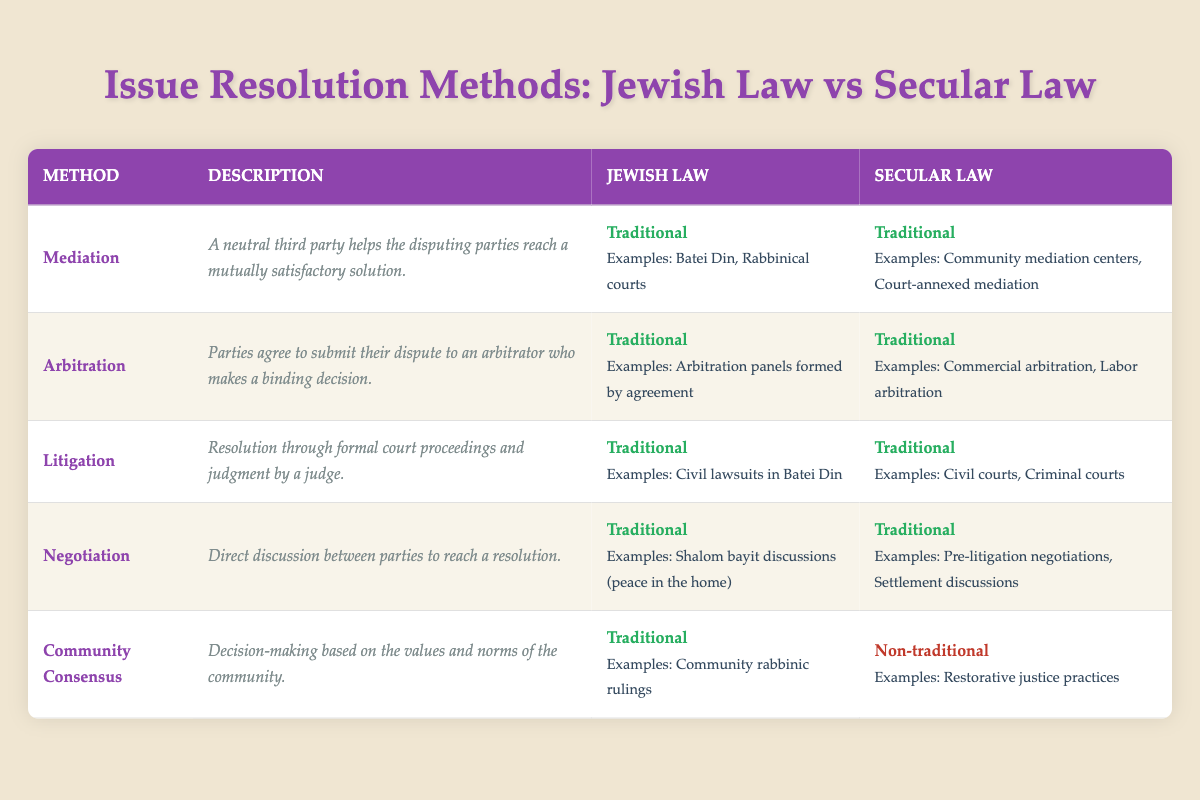What issue resolution method does Jewish law have in common with secular law? Both Jewish law and secular law include Mediation, Arbitration, Litigation, and Negotiation as traditional methods for issue resolution. These methods are listed under their respective columns in the table, and both legal systems feature the same methods classified as traditional.
Answer: Mediation, Arbitration, Litigation, Negotiation Is Community Consensus considered a traditional method in secular law? In the table, Community Consensus is marked as traditional in Jewish law but is noted as non-traditional in secular law. This distinction is explicitly stated in the last row of the table, indicating that it does not fit the traditional model in secular law.
Answer: No What are the examples of Mediation in Jewish law? The examples provided in the table for Mediation in Jewish law are Batei Din and Rabbinical courts, which are clearly listed under the Jewish law column for that method.
Answer: Batei Din, Rabbinical courts How many issue resolution methods are classified as traditional in both Jewish and secular law? By reviewing each row in the table, we see that 4 out of the 5 methods listed (Mediation, Arbitration, Litigation, and Negotiation) are classified as traditional in both legal systems. Community Consensus is the only exception, making it 4 methods in total that share this classification.
Answer: 4 Is it true that all listed methods in Jewish law have examples provided? Upon checking each method in the table, every method listed—Mediation, Arbitration, Litigation, Negotiation, and Community Consensus—has examples included under the Jewish law column. Therefore, the statement is true.
Answer: Yes Which issue resolution method has different classifications between Jewish and secular law? Community Consensus is the only method where Jewish law classifies it as traditional, while secular law classifies it as non-traditional. This unique distinction is found when comparing the respective classifications in the last row of the table.
Answer: Community Consensus What method involves a neutral third party in both legal systems? The method that involves a neutral third party is Mediation, as indicated in the descriptions for both Jewish law and secular law in the table. It explicitly states in both columns that a neutral third party helps the disputing parties reach a mutually satisfactory solution.
Answer: Mediation What would be the total count of traditional methods in Jewish law if Community Consensus were excluded? From the table, there are 5 methods total, 4 of which are classified as traditional, excluding Community Consensus. Since Community Consensus is categorized as traditional in Jewish law but not in the secular column, removing it leaves the total count of traditional methods at 4 for Jewish law.
Answer: 4 